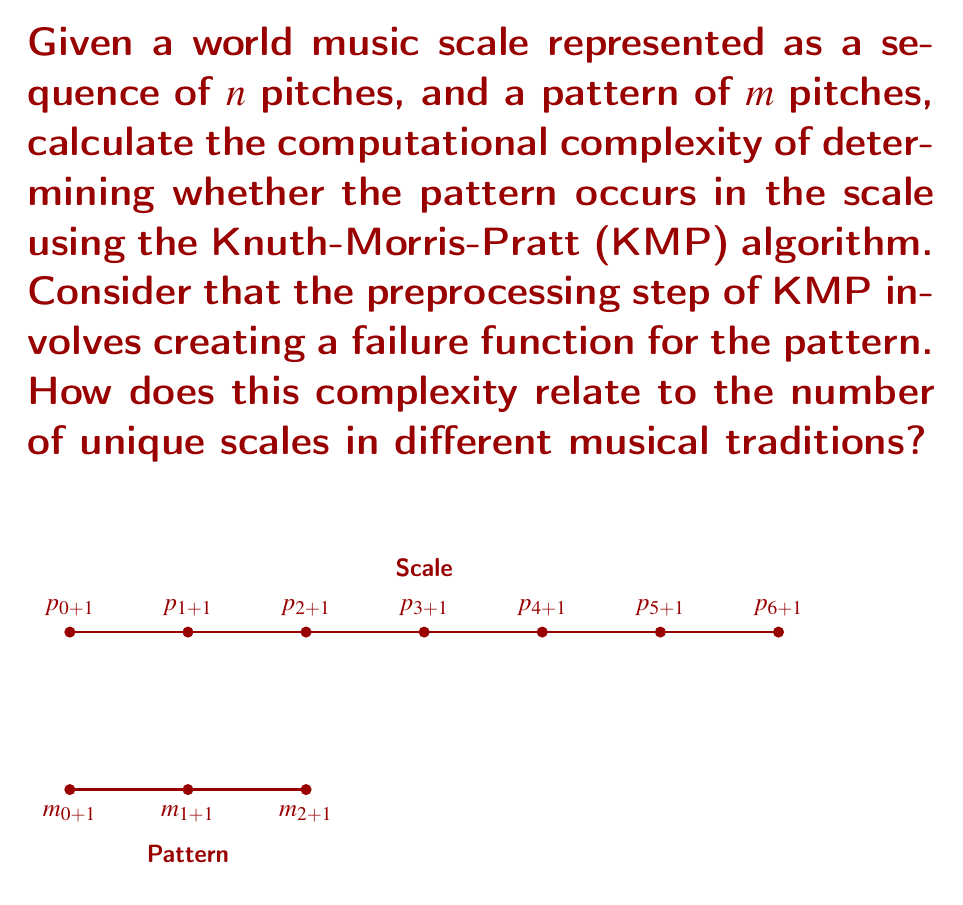Could you help me with this problem? To solve this problem, we need to analyze the Knuth-Morris-Pratt (KMP) algorithm's complexity:

1. Preprocessing step (creating the failure function):
   - Time complexity: $O(m)$
   - Space complexity: $O(m)$
   Where $m$ is the length of the pattern.

2. Pattern matching step:
   - Time complexity: $O(n)$
   Where $n$ is the length of the scale.

3. Total time complexity:
   $O(m) + O(n) = O(m + n)$

4. Total space complexity:
   $O(m)$ for the failure function

The KMP algorithm's efficiency comes from avoiding backtracking in the main search phase, making it linear in the length of the scale.

Relating to world music scales:
- Different musical traditions have varying numbers of unique scales.
- Let's say there are $k$ unique scales in a particular tradition.
- If we want to search for a pattern in all these scales, the time complexity would be:
  $O(k(m + n))$

This analysis shows that the algorithm's efficiency is more dependent on the length of the scales and patterns than on the number of unique scales. However, a large number of scales would linearly increase the overall computation time.
Answer: Time complexity: $O(m + n)$, Space complexity: $O(m)$, where $m$ is pattern length and $n$ is scale length. 